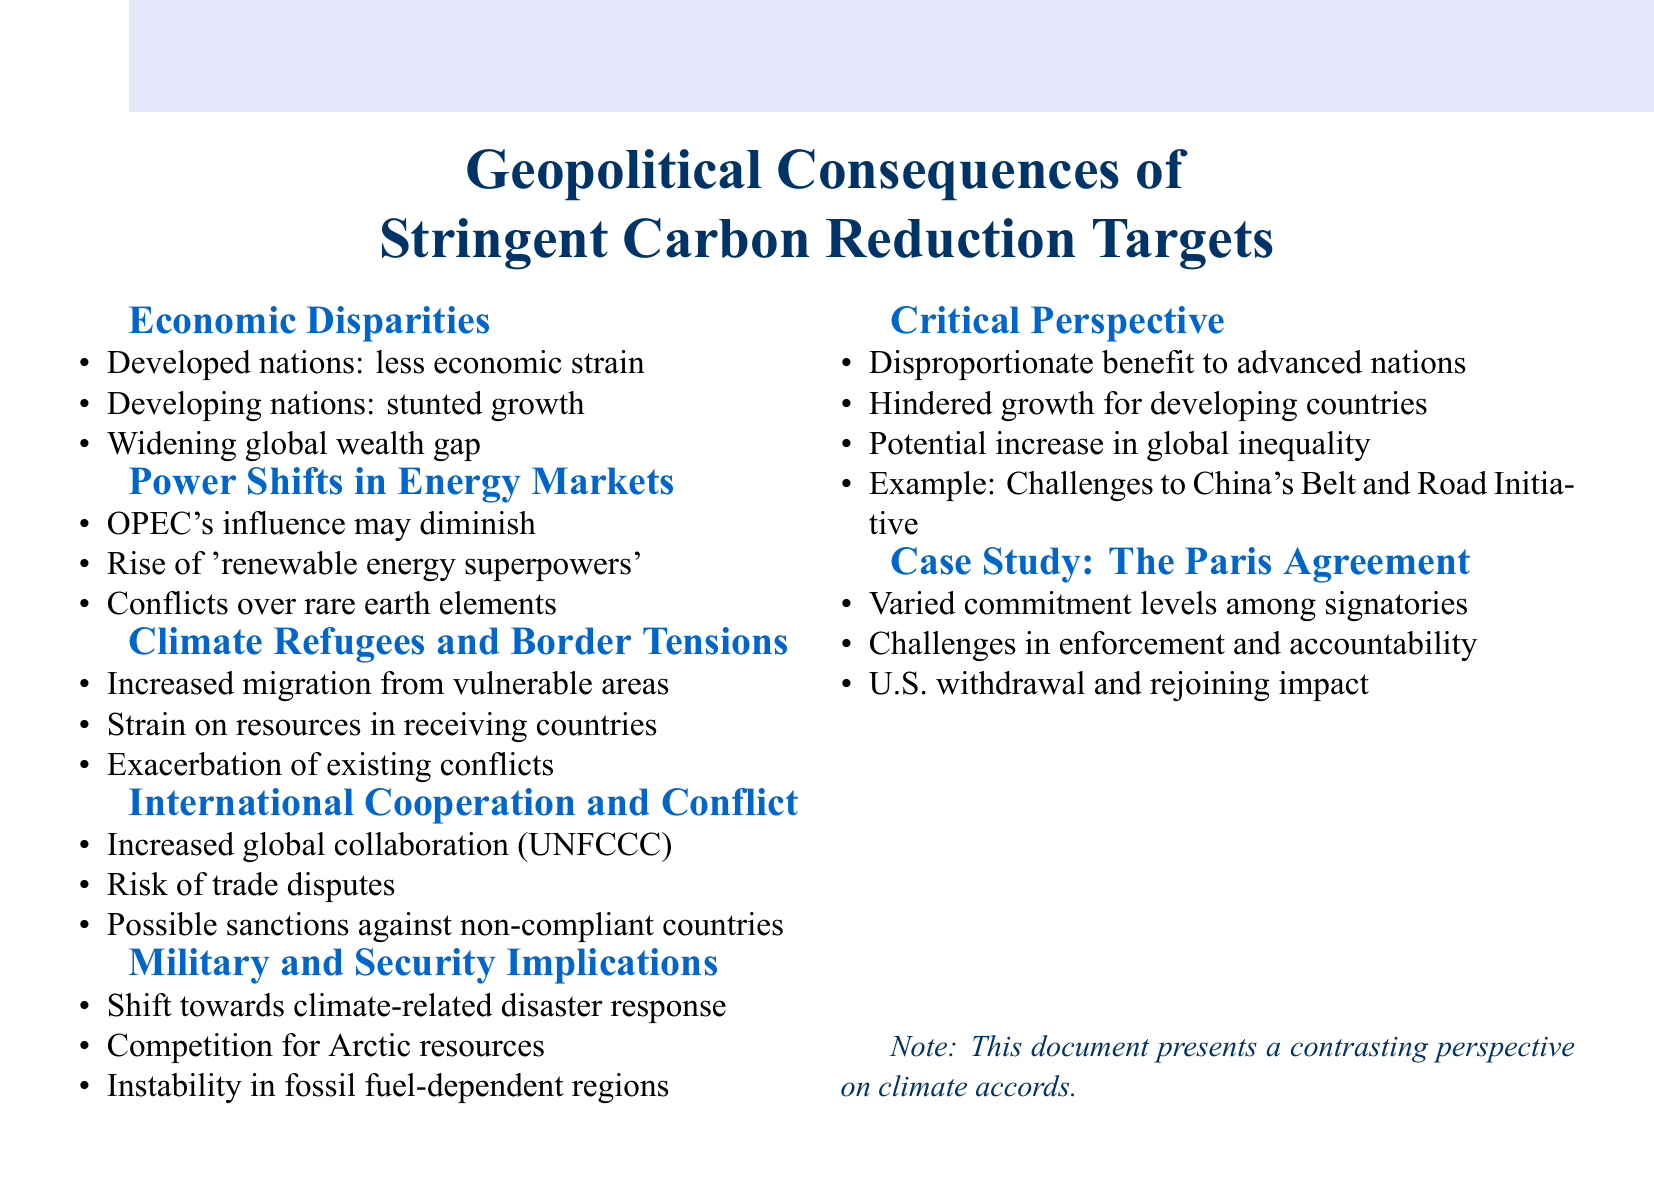What are the two groups mentioned in economic disparities? The document outlines that developed nations like the US and EU could face less strain, while developing nations such as India and Nigeria may experience stunted growth.
Answer: Developed and developing nations Which countries are identified as potential 'renewable energy superpowers'? The document highlights China and Germany as examples of countries that could become 'renewable energy superpowers' due to shifts in energy markets.
Answer: China and Germany What is a possible impact of climate migration mentioned in the document? The document states that increased migration could lead to a strain on resources in countries receiving climate refugees.
Answer: Strain on resources What type of cooperation may increase globally according to the document? The document suggests there may be increased global collaboration through international bodies like the UNFCCC.
Answer: Global collaboration What potential geopolitical shift is associated with military implications? The document indicates a shift in military focus towards climate-related disaster response as a result of geopolitical changes.
Answer: Climate-related disaster response What is a risk associated with international cooperation mentioned? The document discusses the risk of trade disputes arising over carbon border adjustments as a potential conflict.
Answer: Trade disputes Which initiative could face challenges affecting China's global influence? The document mentions China's Belt and Road Initiative facing potential challenges due to stringent carbon reduction targets.
Answer: Belt and Road Initiative What is a challenge faced by signatories of the Paris Agreement? The document highlights varied commitment levels among signatories as a significant challenge.
Answer: Varied commitment levels 